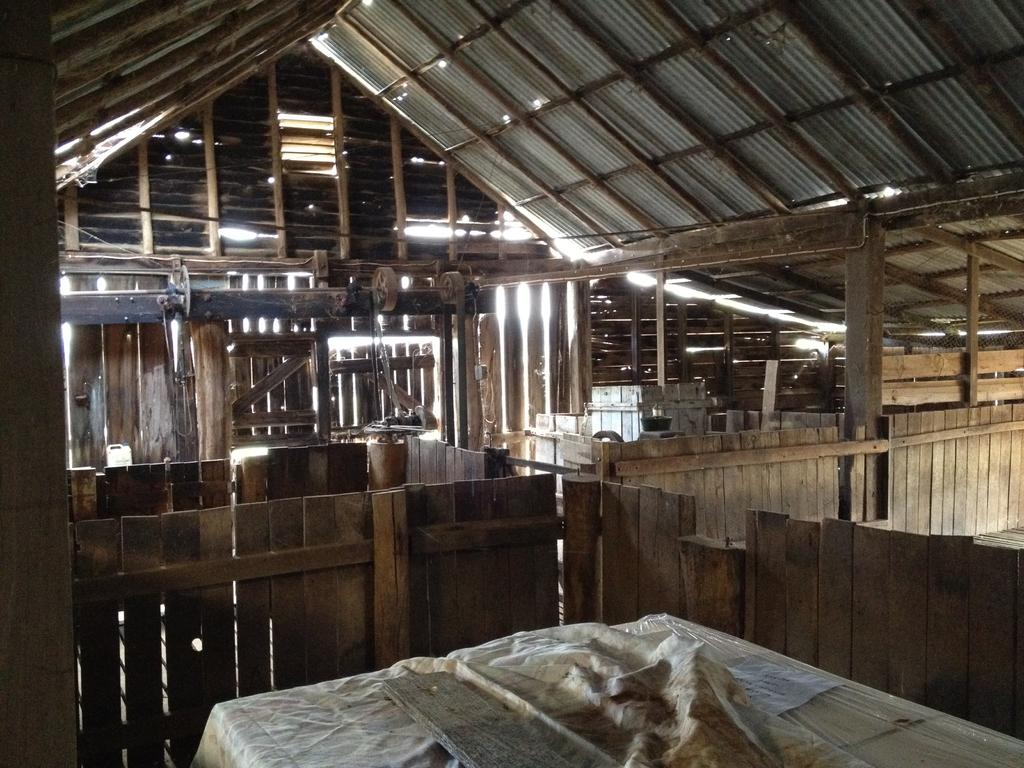What type of material is used for the pillars in the image? The wooden pillars are made of wood. What can be used to enter or exit a room in the image? There are doors in the image that can be used for entering or exiting a room. What is present in the image besides the wooden pillars and doors? There are objects in the image. What is the wooden object placed on at the bottom portion of the image? There is a wooden object placed on a white cloth at the bottom portion of the image. How many apples are hanging from the wooden pillars in the image? There are no apples present in the image; it features wooden pillars and doors. What type of credit card is being used to purchase the wooden object in the image? There is no credit card or any indication of a purchase in the image; it only shows a wooden object placed on a white cloth. 